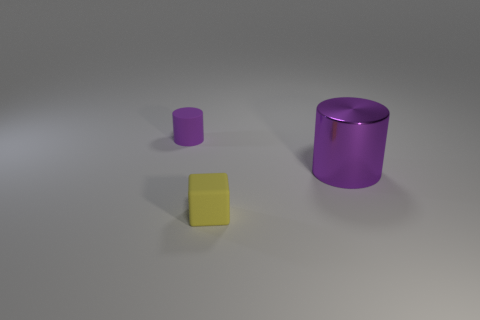Add 1 purple objects. How many objects exist? 4 Subtract all cylinders. How many objects are left? 1 Add 2 small cubes. How many small cubes exist? 3 Subtract 0 purple balls. How many objects are left? 3 Subtract 1 cubes. How many cubes are left? 0 Subtract all blue cylinders. Subtract all purple blocks. How many cylinders are left? 2 Subtract all blue cubes. How many yellow cylinders are left? 0 Subtract all small green metal cubes. Subtract all purple rubber cylinders. How many objects are left? 2 Add 2 shiny things. How many shiny things are left? 3 